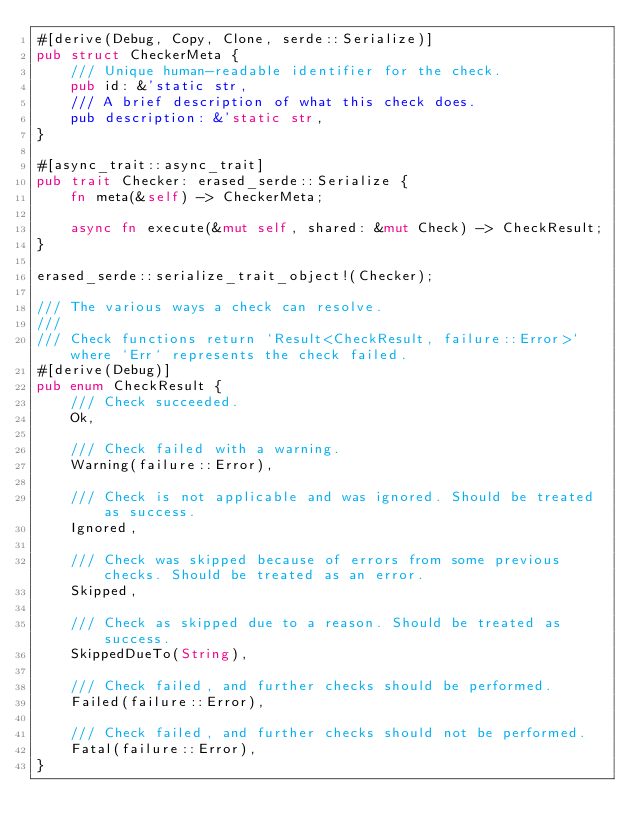<code> <loc_0><loc_0><loc_500><loc_500><_Rust_>#[derive(Debug, Copy, Clone, serde::Serialize)]
pub struct CheckerMeta {
    /// Unique human-readable identifier for the check.
    pub id: &'static str,
    /// A brief description of what this check does.
    pub description: &'static str,
}

#[async_trait::async_trait]
pub trait Checker: erased_serde::Serialize {
    fn meta(&self) -> CheckerMeta;

    async fn execute(&mut self, shared: &mut Check) -> CheckResult;
}

erased_serde::serialize_trait_object!(Checker);

/// The various ways a check can resolve.
///
/// Check functions return `Result<CheckResult, failure::Error>` where `Err` represents the check failed.
#[derive(Debug)]
pub enum CheckResult {
    /// Check succeeded.
    Ok,

    /// Check failed with a warning.
    Warning(failure::Error),

    /// Check is not applicable and was ignored. Should be treated as success.
    Ignored,

    /// Check was skipped because of errors from some previous checks. Should be treated as an error.
    Skipped,

    /// Check as skipped due to a reason. Should be treated as success.
    SkippedDueTo(String),

    /// Check failed, and further checks should be performed.
    Failed(failure::Error),

    /// Check failed, and further checks should not be performed.
    Fatal(failure::Error),
}
</code> 